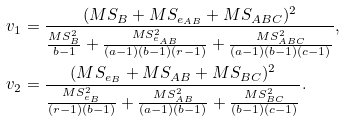Convert formula to latex. <formula><loc_0><loc_0><loc_500><loc_500>v _ { 1 } & = \frac { ( M S _ { B } + M S _ { e _ { A B } } + M S _ { A B C } ) ^ { 2 } } { \frac { M S _ { B } ^ { 2 } } { b - 1 } + \frac { M S _ { e _ { A B } } ^ { 2 } } { ( a - 1 ) ( b - 1 ) ( r - 1 ) } + \frac { M S _ { A B C } ^ { 2 } } { ( a - 1 ) ( b - 1 ) ( c - 1 ) } } , \\ v _ { 2 } & = \frac { ( M S _ { e _ { B } } + M S _ { A B } + M S _ { B C } ) ^ { 2 } } { \frac { M S _ { e _ { B } } ^ { 2 } } { ( r - 1 ) ( b - 1 ) } + \frac { M S _ { A B } ^ { 2 } } { ( a - 1 ) ( b - 1 ) } + \frac { M S _ { B C } ^ { 2 } } { ( b - 1 ) ( c - 1 ) } } .</formula> 